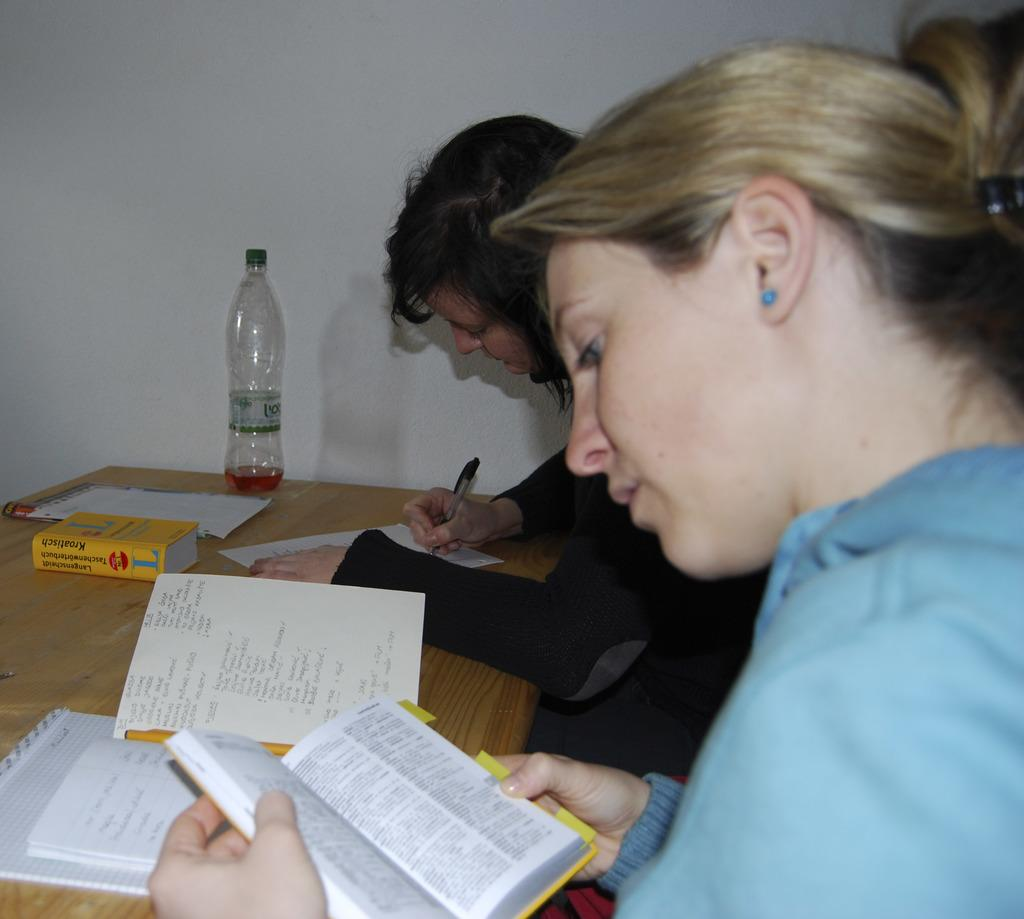Provide a one-sentence caption for the provided image. A yellow book which says, "Kroatisch" sits on a desk where two girls are studying. 